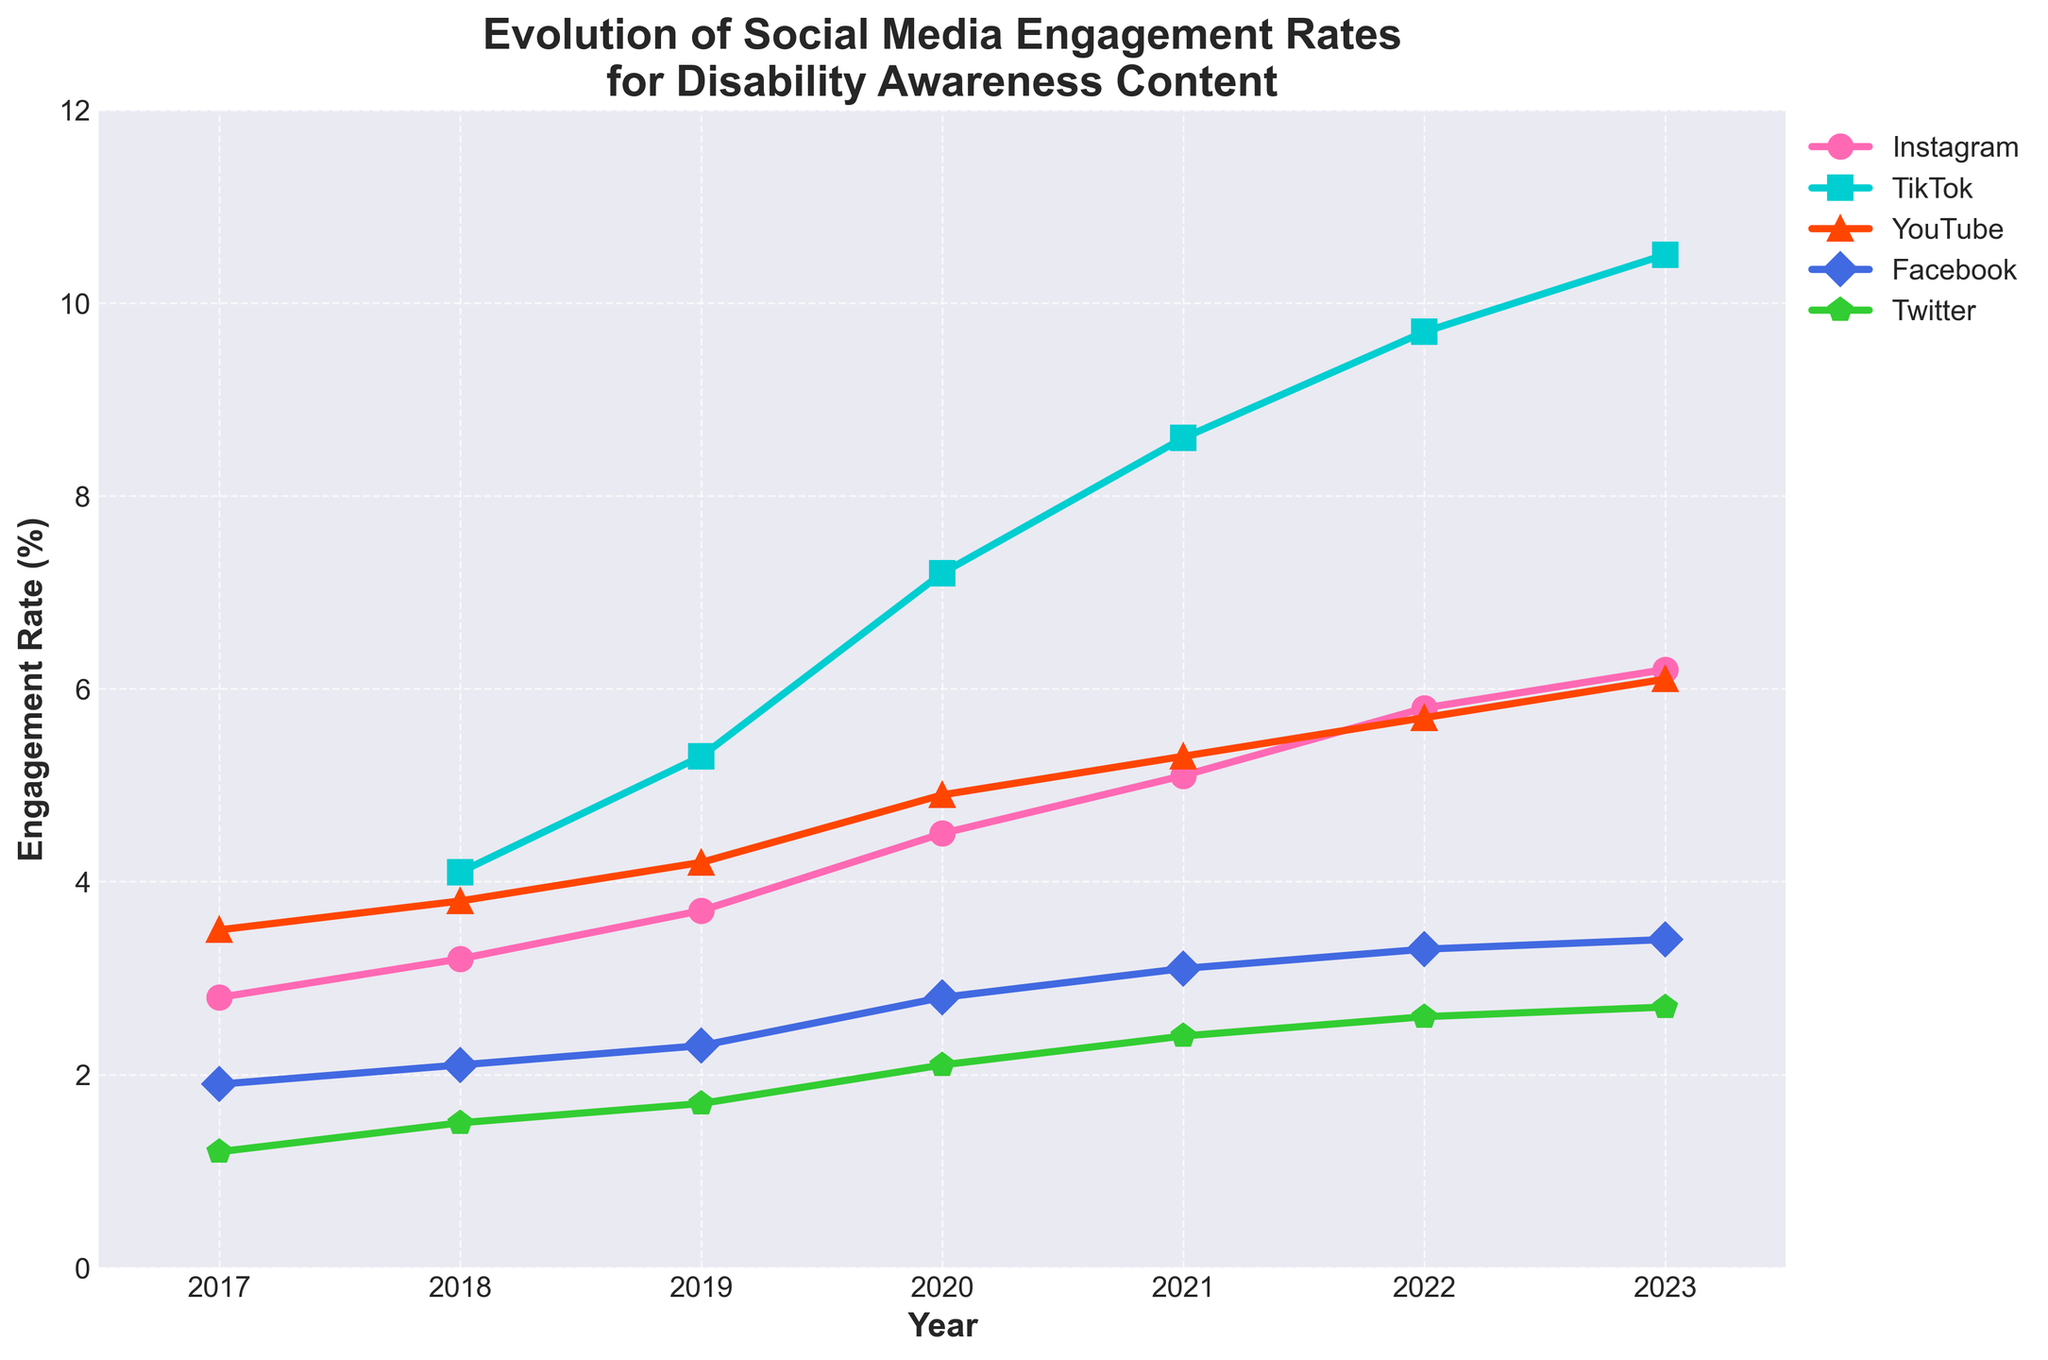Which platform had the highest engagement rate in 2023? Look at the 2023 data points and compare the values for each platform. TikTok has the highest engagement rate at 10.5%.
Answer: TikTok Between which consecutive years did Instagram see the highest increase in engagement rate? Calculate the difference in engagement rate for Instagram between each pair of consecutive years. The highest increase is between 2019 and 2020 where it went from 3.7% to 4.5% (difference of 0.8%).
Answer: 2019 and 2020 How did the engagement rate for Facebook change from 2017 to 2023? Compare the Facebook engagement rate values from 2017 to 2023. The engagement rate increased from 1.9% in 2017 to 3.4% in 2023.
Answer: Increased from 1.9% to 3.4% Which platform saw a consistent increase in engagement rate every year? Observe the trend lines for each platform from 2017 to 2023. Only TikTok and Instagram show a consistent year-over-year increase in engagement rate.
Answer: TikTok and Instagram What is the average engagement rate for YouTube from 2017 to 2023? Sum the engagement rates for YouTube from 2017 to 2023 and divide by the number of years (7). The sum is (3.5% + 3.8% + 4.2% + 4.9% + 5.3% + 5.7% + 6.1%) which equals 33.5%. The average is 33.5%/7.
Answer: 4.79% Compare the engagement rates of Instagram and Twitter in 2020. Which one is higher and by how much? Look at the 2020 data points for Instagram (4.5%) and Twitter (2.1%). Subtract Twitter's rate from Instagram's rate. The difference is 4.5% - 2.1% = 2.4%.
Answer: Instagram by 2.4% Which platform had the lowest engagement rate in 2022? Examine the 2022 data points and identify the platform with the smallest value. Twitter had the lowest engagement rate at 2.6%.
Answer: Twitter Calculate the total increase in engagement rate for TikTok from 2018 to 2023. Subtract TikTok’s engagement rate in 2018 (4.1%) from its engagement rate in 2023 (10.5%) to find the total increase. The difference is 10.5% - 4.1% = 6.4%.
Answer: 6.4% In which year did YouTube surpass a 5% engagement rate? Look for the first year in which YouTube's engagement rate is greater than 5%. YouTube surpassed 5% in 2020 with an engagement rate of 5.3%.
Answer: 2020 Which platform experienced the most significant increase in engagement rate between the years 2021 and 2022? Calculate the difference in engagement rates between 2021 and 2022 for each platform. TikTok had the largest increase from 8.6% to 9.7%, which is an increase of 1.1%.
Answer: TikTok 